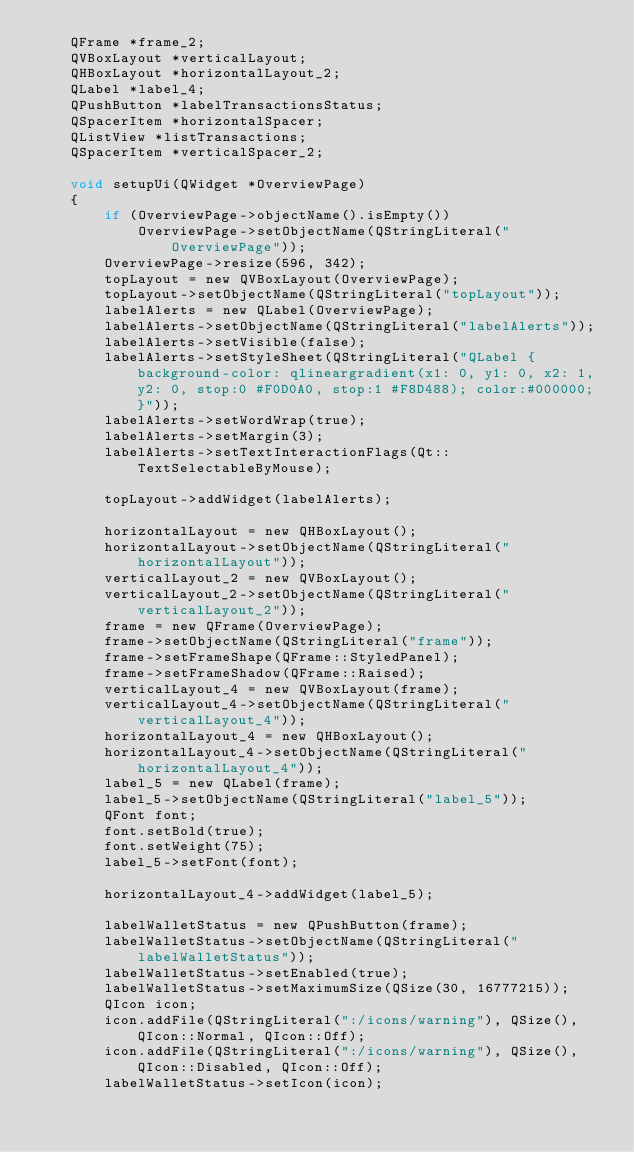<code> <loc_0><loc_0><loc_500><loc_500><_C_>    QFrame *frame_2;
    QVBoxLayout *verticalLayout;
    QHBoxLayout *horizontalLayout_2;
    QLabel *label_4;
    QPushButton *labelTransactionsStatus;
    QSpacerItem *horizontalSpacer;
    QListView *listTransactions;
    QSpacerItem *verticalSpacer_2;

    void setupUi(QWidget *OverviewPage)
    {
        if (OverviewPage->objectName().isEmpty())
            OverviewPage->setObjectName(QStringLiteral("OverviewPage"));
        OverviewPage->resize(596, 342);
        topLayout = new QVBoxLayout(OverviewPage);
        topLayout->setObjectName(QStringLiteral("topLayout"));
        labelAlerts = new QLabel(OverviewPage);
        labelAlerts->setObjectName(QStringLiteral("labelAlerts"));
        labelAlerts->setVisible(false);
        labelAlerts->setStyleSheet(QStringLiteral("QLabel { background-color: qlineargradient(x1: 0, y1: 0, x2: 1, y2: 0, stop:0 #F0D0A0, stop:1 #F8D488); color:#000000; }"));
        labelAlerts->setWordWrap(true);
        labelAlerts->setMargin(3);
        labelAlerts->setTextInteractionFlags(Qt::TextSelectableByMouse);

        topLayout->addWidget(labelAlerts);

        horizontalLayout = new QHBoxLayout();
        horizontalLayout->setObjectName(QStringLiteral("horizontalLayout"));
        verticalLayout_2 = new QVBoxLayout();
        verticalLayout_2->setObjectName(QStringLiteral("verticalLayout_2"));
        frame = new QFrame(OverviewPage);
        frame->setObjectName(QStringLiteral("frame"));
        frame->setFrameShape(QFrame::StyledPanel);
        frame->setFrameShadow(QFrame::Raised);
        verticalLayout_4 = new QVBoxLayout(frame);
        verticalLayout_4->setObjectName(QStringLiteral("verticalLayout_4"));
        horizontalLayout_4 = new QHBoxLayout();
        horizontalLayout_4->setObjectName(QStringLiteral("horizontalLayout_4"));
        label_5 = new QLabel(frame);
        label_5->setObjectName(QStringLiteral("label_5"));
        QFont font;
        font.setBold(true);
        font.setWeight(75);
        label_5->setFont(font);

        horizontalLayout_4->addWidget(label_5);

        labelWalletStatus = new QPushButton(frame);
        labelWalletStatus->setObjectName(QStringLiteral("labelWalletStatus"));
        labelWalletStatus->setEnabled(true);
        labelWalletStatus->setMaximumSize(QSize(30, 16777215));
        QIcon icon;
        icon.addFile(QStringLiteral(":/icons/warning"), QSize(), QIcon::Normal, QIcon::Off);
        icon.addFile(QStringLiteral(":/icons/warning"), QSize(), QIcon::Disabled, QIcon::Off);
        labelWalletStatus->setIcon(icon);</code> 